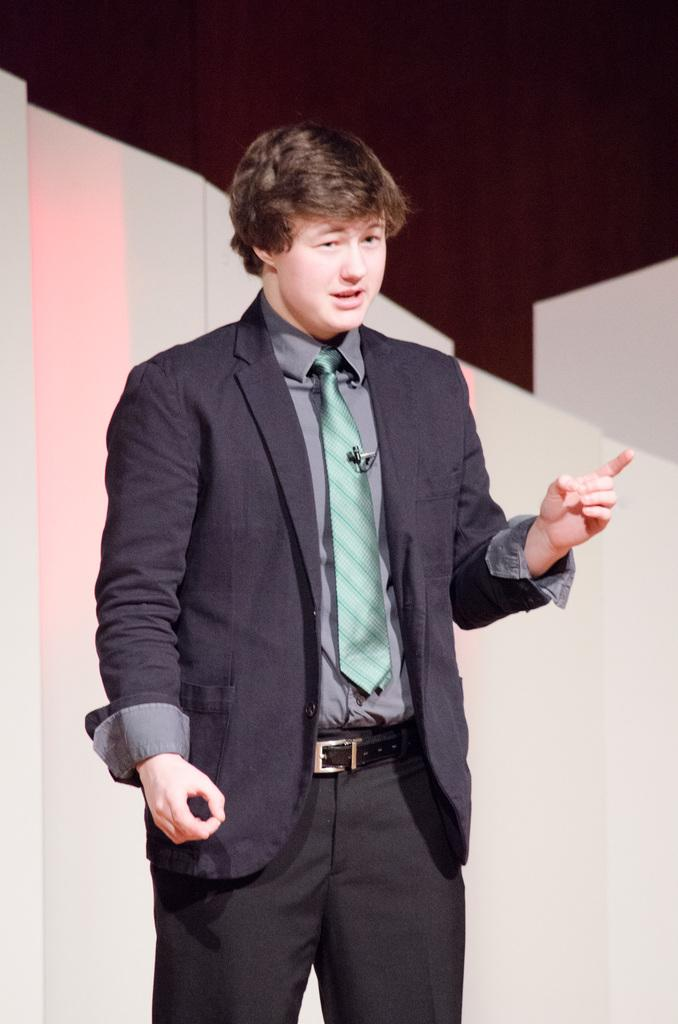What is the man in the image wearing? The man is wearing a suit, a shirt, a tie, a belt, and trousers. What can be seen in the background of the image? The background of the image appears to be a wall. What is the color scheme of the wall in the image? The wall has a black and white color scheme. What type of vase can be seen in the image? There is no vase present in the image. What shape is the sack that the man is carrying in the image? The man is not carrying a sack in the image. 